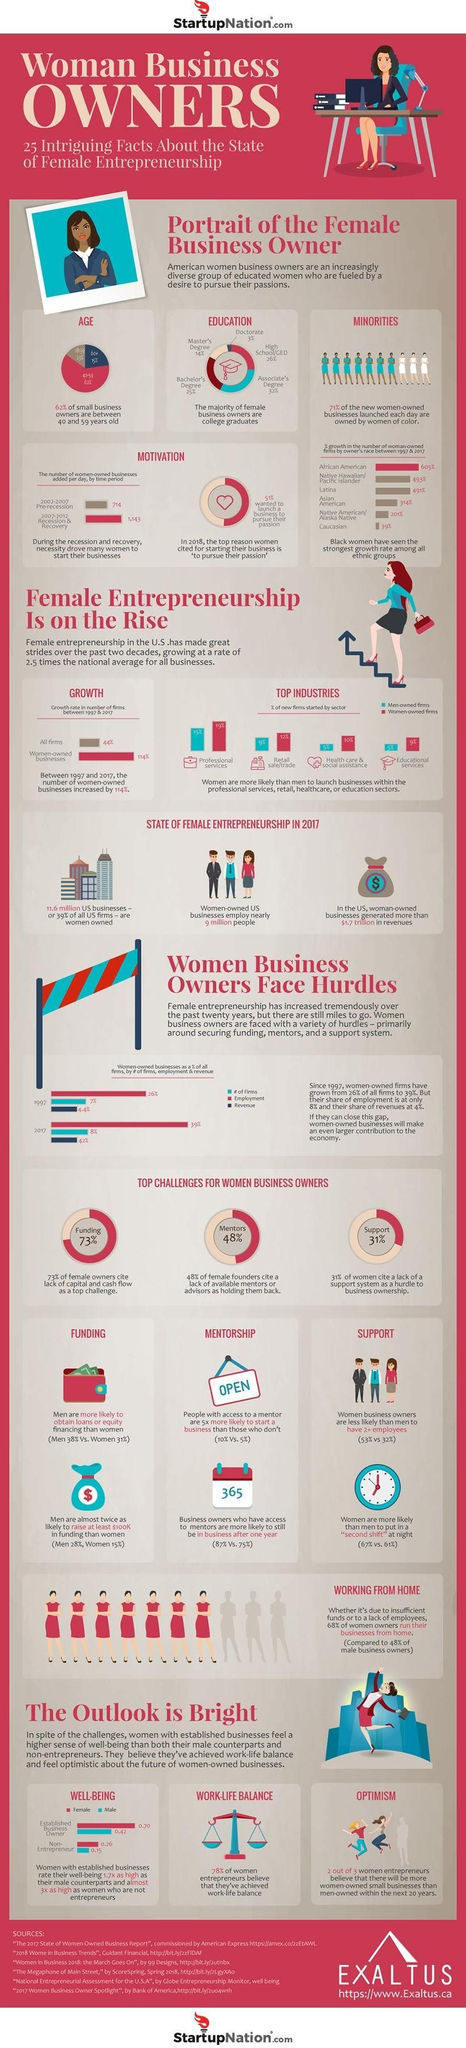What has been the growth in women owned business added per day post recession?
Answer the question with a short phrase. 429 per day What is the percentage of small business owners who are senior citizens? 15% What percentage of business owners are graduates, 25%, 26%, or 32%? 25% Which industry has the highest percentage of women owned firms? Professional services What is the rate of employment in women owned firms in 2017? 39% What percentage of women cite lack of access to mentorship as a hurdle, 73%, 48%, or 31%? 48% What is the rate of well being among non-entrepreneurial women? 0.26 